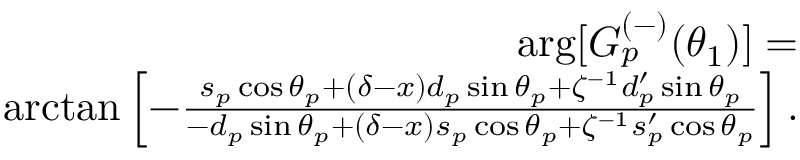Convert formula to latex. <formula><loc_0><loc_0><loc_500><loc_500>\begin{array} { r l r } & { \arg [ G _ { p } ^ { ( - ) } ( \theta _ { 1 } ) ] = } \\ & { \arctan \left [ - \frac { s _ { p } \cos \theta _ { p } + \left ( \delta - x \right ) d _ { p } \sin \theta _ { p } + \zeta ^ { - 1 } d _ { p } ^ { \prime } \sin \theta _ { p } } { - d _ { p } \sin \theta _ { p } + \left ( \delta - x \right ) s _ { p } \cos \theta _ { p } + \zeta ^ { - 1 } s _ { p } ^ { \prime } \cos \theta _ { p } } \right ] . } \end{array}</formula> 